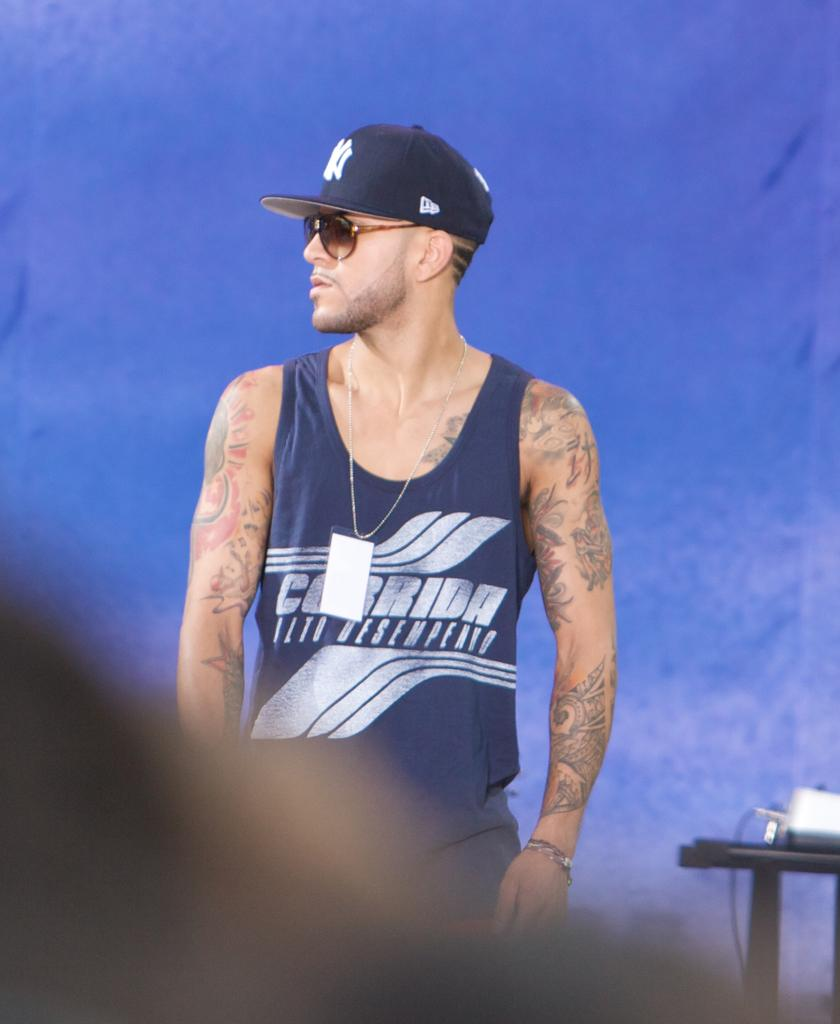Where was the image taken? The image was taken indoors. What can be seen in the background of the image? There is a wall in the background of the image. What is on the right side of the image? There is a table with a few things on it on the right side of the image. Who is in the image? There is a man in the middle of the image. What type of gold offer does the man make in the image? There is no mention of gold or an offer in the image; it simply shows a man in the middle of the room. 